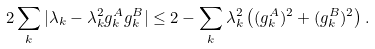Convert formula to latex. <formula><loc_0><loc_0><loc_500><loc_500>2 \sum _ { k } | \lambda _ { k } - \lambda _ { k } ^ { 2 } g _ { k } ^ { A } g _ { k } ^ { B } | \leq 2 - \sum _ { k } \lambda _ { k } ^ { 2 } \left ( ( g _ { k } ^ { A } ) ^ { 2 } + ( g _ { k } ^ { B } ) ^ { 2 } \right ) .</formula> 